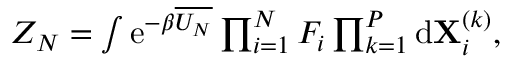<formula> <loc_0><loc_0><loc_500><loc_500>\begin{array} { r } { Z _ { N } = \int e ^ { - \beta \overline { { U _ { N } } } } \prod _ { i = 1 } ^ { N } F _ { i } \prod _ { k = 1 } ^ { P } d X _ { i } ^ { ( k ) } , } \end{array}</formula> 